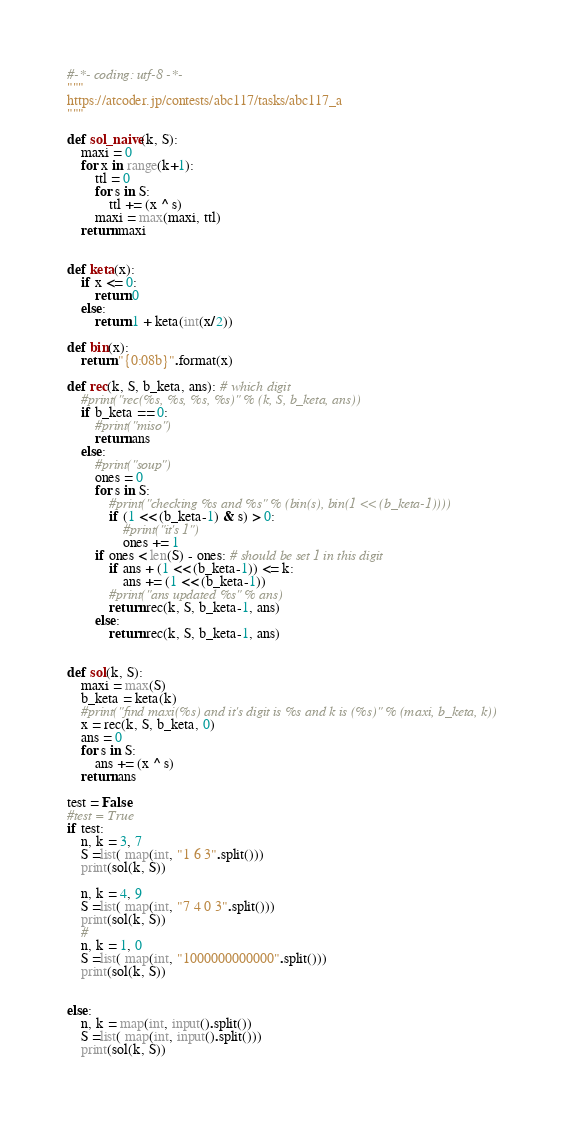Convert code to text. <code><loc_0><loc_0><loc_500><loc_500><_Python_>#-*- coding: utf-8 -*-
"""
https://atcoder.jp/contests/abc117/tasks/abc117_a
"""

def sol_naive(k, S):
    maxi = 0
    for x in range(k+1):
        ttl = 0
        for s in S:
            ttl += (x ^ s)
        maxi = max(maxi, ttl)
    return maxi


def keta(x):
    if x <= 0:
        return 0
    else:
        return 1 + keta(int(x/2))

def bin(x):
    return "{0:08b}".format(x)

def rec(k, S, b_keta, ans): # which digit
    #print("rec(%s, %s, %s, %s)" % (k, S, b_keta, ans))
    if b_keta == 0:
        #print("miso")
        return ans
    else:
        #print("soup")
        ones = 0
        for s in S:
            #print("checking %s and %s" % (bin(s), bin(1 << (b_keta-1))))
            if (1 << (b_keta-1) & s) > 0:
                #print("it's 1")
                ones += 1
        if ones < len(S) - ones: # should be set 1 in this digit
            if ans + (1 << (b_keta-1)) <= k:
                ans += (1 << (b_keta-1))
            #print("ans updated %s" % ans)
            return rec(k, S, b_keta-1, ans)
        else:
            return rec(k, S, b_keta-1, ans)


def sol(k, S):
    maxi = max(S)
    b_keta = keta(k)
    #print("find maxi(%s) and it's digit is %s and k is (%s)" % (maxi, b_keta, k))
    x = rec(k, S, b_keta, 0)
    ans = 0
    for s in S:
        ans += (x ^ s)
    return ans

test = False
#test = True
if test:
    n, k = 3, 7
    S =list( map(int, "1 6 3".split()))
    print(sol(k, S))

    n, k = 4, 9
    S =list( map(int, "7 4 0 3".split()))
    print(sol(k, S))
    #
    n, k = 1, 0
    S =list( map(int, "1000000000000".split()))
    print(sol(k, S))


else:
    n, k = map(int, input().split())
    S =list( map(int, input().split()))
    print(sol(k, S))


</code> 